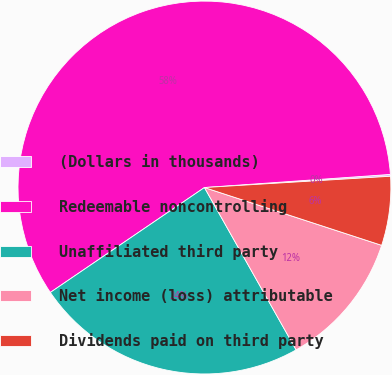<chart> <loc_0><loc_0><loc_500><loc_500><pie_chart><fcel>(Dollars in thousands)<fcel>Redeemable noncontrolling<fcel>Unaffiliated third party<fcel>Net income (loss) attributable<fcel>Dividends paid on third party<nl><fcel>0.16%<fcel>58.39%<fcel>23.67%<fcel>11.8%<fcel>5.98%<nl></chart> 